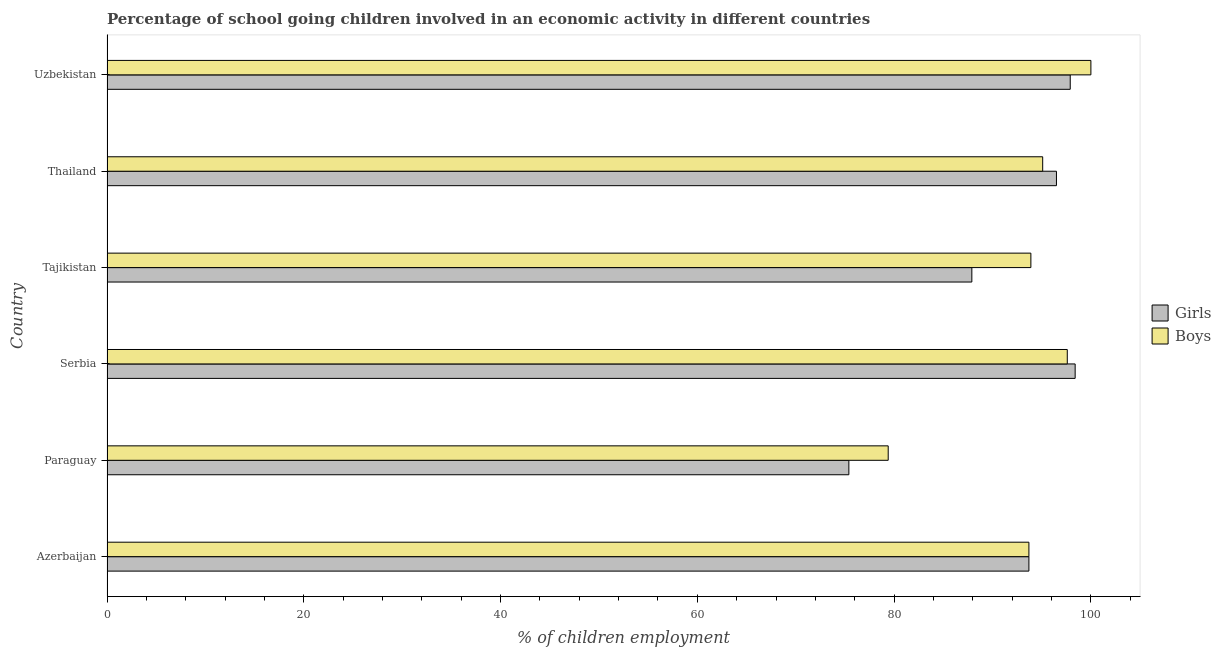How many different coloured bars are there?
Your answer should be compact. 2. How many groups of bars are there?
Your answer should be very brief. 6. Are the number of bars per tick equal to the number of legend labels?
Make the answer very short. Yes. How many bars are there on the 4th tick from the top?
Your answer should be compact. 2. How many bars are there on the 4th tick from the bottom?
Your answer should be compact. 2. What is the label of the 6th group of bars from the top?
Give a very brief answer. Azerbaijan. In how many cases, is the number of bars for a given country not equal to the number of legend labels?
Offer a very short reply. 0. What is the percentage of school going girls in Azerbaijan?
Ensure brevity in your answer.  93.7. Across all countries, what is the maximum percentage of school going boys?
Your response must be concise. 100. Across all countries, what is the minimum percentage of school going boys?
Offer a terse response. 79.4. In which country was the percentage of school going girls maximum?
Your answer should be compact. Serbia. In which country was the percentage of school going boys minimum?
Provide a succinct answer. Paraguay. What is the total percentage of school going girls in the graph?
Give a very brief answer. 549.8. What is the difference between the percentage of school going boys in Serbia and the percentage of school going girls in Tajikistan?
Your answer should be compact. 9.7. What is the average percentage of school going girls per country?
Make the answer very short. 91.63. What is the difference between the percentage of school going girls and percentage of school going boys in Azerbaijan?
Your answer should be very brief. 0. What is the ratio of the percentage of school going boys in Azerbaijan to that in Uzbekistan?
Provide a short and direct response. 0.94. Is the percentage of school going girls in Serbia less than that in Uzbekistan?
Your answer should be very brief. No. Is the difference between the percentage of school going boys in Azerbaijan and Paraguay greater than the difference between the percentage of school going girls in Azerbaijan and Paraguay?
Offer a terse response. No. What is the difference between the highest and the lowest percentage of school going girls?
Your response must be concise. 23. Is the sum of the percentage of school going boys in Serbia and Uzbekistan greater than the maximum percentage of school going girls across all countries?
Provide a short and direct response. Yes. What does the 1st bar from the top in Azerbaijan represents?
Make the answer very short. Boys. What does the 1st bar from the bottom in Azerbaijan represents?
Offer a very short reply. Girls. How many bars are there?
Keep it short and to the point. 12. How many countries are there in the graph?
Your answer should be very brief. 6. Where does the legend appear in the graph?
Offer a terse response. Center right. What is the title of the graph?
Offer a very short reply. Percentage of school going children involved in an economic activity in different countries. What is the label or title of the X-axis?
Your response must be concise. % of children employment. What is the label or title of the Y-axis?
Provide a short and direct response. Country. What is the % of children employment of Girls in Azerbaijan?
Ensure brevity in your answer.  93.7. What is the % of children employment in Boys in Azerbaijan?
Offer a very short reply. 93.7. What is the % of children employment of Girls in Paraguay?
Keep it short and to the point. 75.4. What is the % of children employment of Boys in Paraguay?
Ensure brevity in your answer.  79.4. What is the % of children employment of Girls in Serbia?
Offer a very short reply. 98.4. What is the % of children employment of Boys in Serbia?
Offer a terse response. 97.6. What is the % of children employment of Girls in Tajikistan?
Offer a terse response. 87.9. What is the % of children employment in Boys in Tajikistan?
Offer a very short reply. 93.9. What is the % of children employment in Girls in Thailand?
Ensure brevity in your answer.  96.5. What is the % of children employment of Boys in Thailand?
Provide a short and direct response. 95.1. What is the % of children employment in Girls in Uzbekistan?
Provide a short and direct response. 97.9. What is the % of children employment in Boys in Uzbekistan?
Your answer should be very brief. 100. Across all countries, what is the maximum % of children employment in Girls?
Offer a very short reply. 98.4. Across all countries, what is the maximum % of children employment in Boys?
Provide a short and direct response. 100. Across all countries, what is the minimum % of children employment in Girls?
Your answer should be very brief. 75.4. Across all countries, what is the minimum % of children employment in Boys?
Make the answer very short. 79.4. What is the total % of children employment of Girls in the graph?
Your answer should be compact. 549.8. What is the total % of children employment of Boys in the graph?
Provide a succinct answer. 559.7. What is the difference between the % of children employment in Girls in Azerbaijan and that in Paraguay?
Your answer should be compact. 18.3. What is the difference between the % of children employment in Boys in Azerbaijan and that in Paraguay?
Your response must be concise. 14.3. What is the difference between the % of children employment in Girls in Azerbaijan and that in Serbia?
Give a very brief answer. -4.7. What is the difference between the % of children employment in Boys in Azerbaijan and that in Serbia?
Make the answer very short. -3.9. What is the difference between the % of children employment in Girls in Azerbaijan and that in Tajikistan?
Your answer should be very brief. 5.8. What is the difference between the % of children employment of Boys in Azerbaijan and that in Tajikistan?
Make the answer very short. -0.2. What is the difference between the % of children employment of Girls in Azerbaijan and that in Thailand?
Provide a succinct answer. -2.8. What is the difference between the % of children employment of Girls in Paraguay and that in Serbia?
Your answer should be very brief. -23. What is the difference between the % of children employment of Boys in Paraguay and that in Serbia?
Give a very brief answer. -18.2. What is the difference between the % of children employment in Boys in Paraguay and that in Tajikistan?
Give a very brief answer. -14.5. What is the difference between the % of children employment of Girls in Paraguay and that in Thailand?
Your answer should be very brief. -21.1. What is the difference between the % of children employment in Boys in Paraguay and that in Thailand?
Offer a very short reply. -15.7. What is the difference between the % of children employment of Girls in Paraguay and that in Uzbekistan?
Provide a succinct answer. -22.5. What is the difference between the % of children employment of Boys in Paraguay and that in Uzbekistan?
Provide a short and direct response. -20.6. What is the difference between the % of children employment in Girls in Serbia and that in Tajikistan?
Your answer should be very brief. 10.5. What is the difference between the % of children employment in Boys in Serbia and that in Tajikistan?
Keep it short and to the point. 3.7. What is the difference between the % of children employment in Boys in Serbia and that in Thailand?
Provide a short and direct response. 2.5. What is the difference between the % of children employment of Boys in Tajikistan and that in Thailand?
Provide a short and direct response. -1.2. What is the difference between the % of children employment in Girls in Tajikistan and that in Uzbekistan?
Your answer should be compact. -10. What is the difference between the % of children employment of Boys in Tajikistan and that in Uzbekistan?
Offer a very short reply. -6.1. What is the difference between the % of children employment in Girls in Azerbaijan and the % of children employment in Boys in Paraguay?
Your answer should be compact. 14.3. What is the difference between the % of children employment in Girls in Azerbaijan and the % of children employment in Boys in Serbia?
Your answer should be very brief. -3.9. What is the difference between the % of children employment in Girls in Azerbaijan and the % of children employment in Boys in Thailand?
Offer a terse response. -1.4. What is the difference between the % of children employment in Girls in Azerbaijan and the % of children employment in Boys in Uzbekistan?
Your answer should be compact. -6.3. What is the difference between the % of children employment of Girls in Paraguay and the % of children employment of Boys in Serbia?
Offer a very short reply. -22.2. What is the difference between the % of children employment in Girls in Paraguay and the % of children employment in Boys in Tajikistan?
Your answer should be compact. -18.5. What is the difference between the % of children employment in Girls in Paraguay and the % of children employment in Boys in Thailand?
Make the answer very short. -19.7. What is the difference between the % of children employment in Girls in Paraguay and the % of children employment in Boys in Uzbekistan?
Ensure brevity in your answer.  -24.6. What is the difference between the % of children employment of Girls in Serbia and the % of children employment of Boys in Uzbekistan?
Offer a terse response. -1.6. What is the difference between the % of children employment in Girls in Tajikistan and the % of children employment in Boys in Thailand?
Provide a succinct answer. -7.2. What is the difference between the % of children employment of Girls in Tajikistan and the % of children employment of Boys in Uzbekistan?
Your answer should be very brief. -12.1. What is the difference between the % of children employment of Girls in Thailand and the % of children employment of Boys in Uzbekistan?
Make the answer very short. -3.5. What is the average % of children employment in Girls per country?
Your answer should be very brief. 91.63. What is the average % of children employment of Boys per country?
Your answer should be very brief. 93.28. What is the difference between the % of children employment in Girls and % of children employment in Boys in Paraguay?
Provide a succinct answer. -4. What is the difference between the % of children employment of Girls and % of children employment of Boys in Serbia?
Your answer should be very brief. 0.8. What is the difference between the % of children employment in Girls and % of children employment in Boys in Uzbekistan?
Provide a succinct answer. -2.1. What is the ratio of the % of children employment of Girls in Azerbaijan to that in Paraguay?
Provide a succinct answer. 1.24. What is the ratio of the % of children employment of Boys in Azerbaijan to that in Paraguay?
Give a very brief answer. 1.18. What is the ratio of the % of children employment of Girls in Azerbaijan to that in Serbia?
Your answer should be compact. 0.95. What is the ratio of the % of children employment in Boys in Azerbaijan to that in Serbia?
Keep it short and to the point. 0.96. What is the ratio of the % of children employment of Girls in Azerbaijan to that in Tajikistan?
Your answer should be compact. 1.07. What is the ratio of the % of children employment of Boys in Azerbaijan to that in Tajikistan?
Your answer should be compact. 1. What is the ratio of the % of children employment of Girls in Azerbaijan to that in Thailand?
Provide a short and direct response. 0.97. What is the ratio of the % of children employment of Girls in Azerbaijan to that in Uzbekistan?
Offer a very short reply. 0.96. What is the ratio of the % of children employment in Boys in Azerbaijan to that in Uzbekistan?
Keep it short and to the point. 0.94. What is the ratio of the % of children employment of Girls in Paraguay to that in Serbia?
Provide a short and direct response. 0.77. What is the ratio of the % of children employment of Boys in Paraguay to that in Serbia?
Your response must be concise. 0.81. What is the ratio of the % of children employment of Girls in Paraguay to that in Tajikistan?
Provide a short and direct response. 0.86. What is the ratio of the % of children employment in Boys in Paraguay to that in Tajikistan?
Your answer should be very brief. 0.85. What is the ratio of the % of children employment of Girls in Paraguay to that in Thailand?
Give a very brief answer. 0.78. What is the ratio of the % of children employment of Boys in Paraguay to that in Thailand?
Your response must be concise. 0.83. What is the ratio of the % of children employment of Girls in Paraguay to that in Uzbekistan?
Your answer should be very brief. 0.77. What is the ratio of the % of children employment of Boys in Paraguay to that in Uzbekistan?
Your response must be concise. 0.79. What is the ratio of the % of children employment in Girls in Serbia to that in Tajikistan?
Keep it short and to the point. 1.12. What is the ratio of the % of children employment of Boys in Serbia to that in Tajikistan?
Offer a terse response. 1.04. What is the ratio of the % of children employment of Girls in Serbia to that in Thailand?
Your answer should be compact. 1.02. What is the ratio of the % of children employment of Boys in Serbia to that in Thailand?
Provide a succinct answer. 1.03. What is the ratio of the % of children employment of Girls in Serbia to that in Uzbekistan?
Your answer should be very brief. 1.01. What is the ratio of the % of children employment of Boys in Serbia to that in Uzbekistan?
Your answer should be compact. 0.98. What is the ratio of the % of children employment of Girls in Tajikistan to that in Thailand?
Offer a terse response. 0.91. What is the ratio of the % of children employment in Boys in Tajikistan to that in Thailand?
Provide a succinct answer. 0.99. What is the ratio of the % of children employment in Girls in Tajikistan to that in Uzbekistan?
Provide a short and direct response. 0.9. What is the ratio of the % of children employment of Boys in Tajikistan to that in Uzbekistan?
Make the answer very short. 0.94. What is the ratio of the % of children employment of Girls in Thailand to that in Uzbekistan?
Provide a succinct answer. 0.99. What is the ratio of the % of children employment of Boys in Thailand to that in Uzbekistan?
Your response must be concise. 0.95. What is the difference between the highest and the second highest % of children employment of Boys?
Offer a very short reply. 2.4. What is the difference between the highest and the lowest % of children employment in Girls?
Keep it short and to the point. 23. What is the difference between the highest and the lowest % of children employment of Boys?
Make the answer very short. 20.6. 